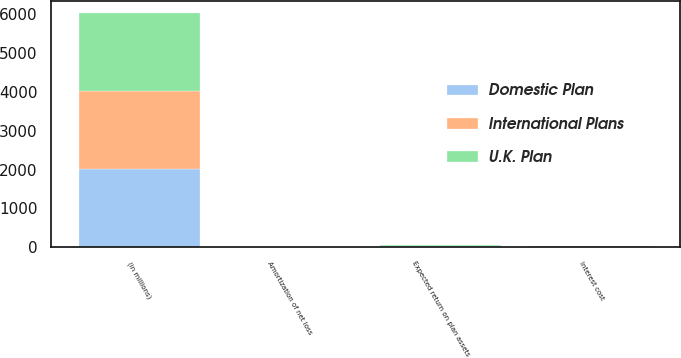Convert chart to OTSL. <chart><loc_0><loc_0><loc_500><loc_500><stacked_bar_chart><ecel><fcel>(in millions)<fcel>Interest cost<fcel>Expected return on plan assets<fcel>Amortization of net loss<nl><fcel>U.K. Plan<fcel>2014<fcel>17<fcel>18<fcel>1<nl><fcel>Domestic Plan<fcel>2014<fcel>17<fcel>24<fcel>1<nl><fcel>International Plans<fcel>2014<fcel>4<fcel>4<fcel>1<nl></chart> 